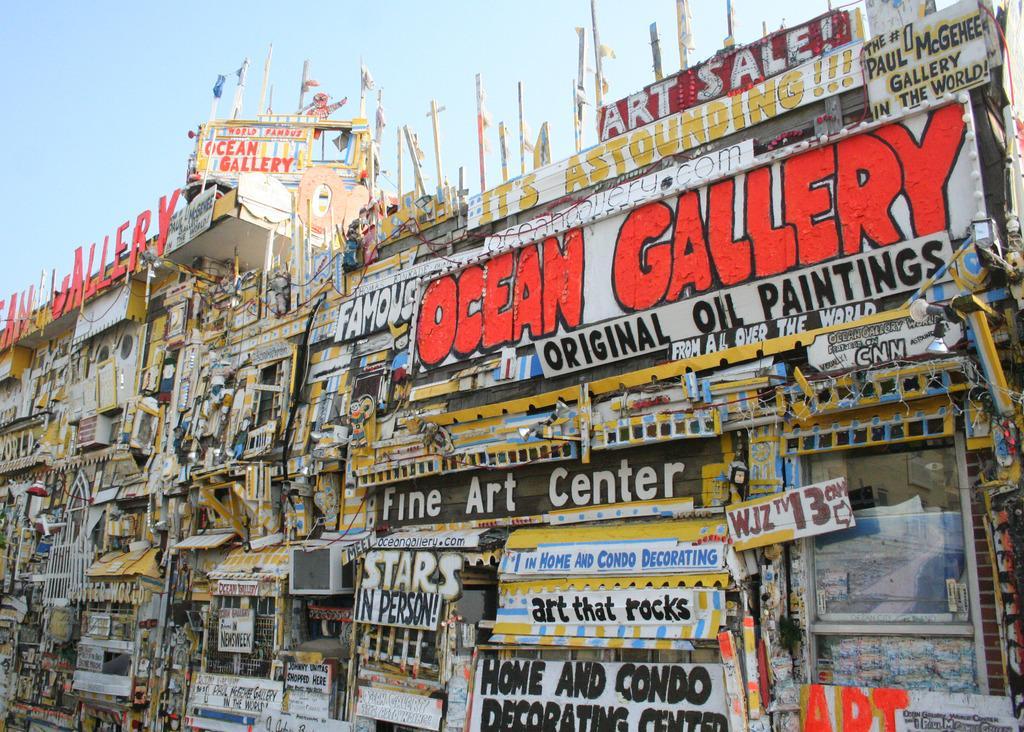Could you give a brief overview of what you see in this image? In this image, on the buildings there are some boards and posters with text written on it. On the buildings there are poles. 